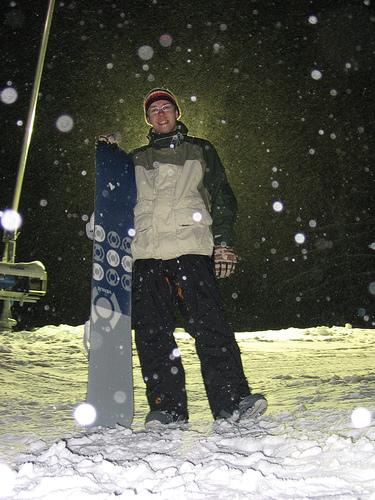What is the man holding?
Give a very brief answer. Snowboard. Is it snowing?
Short answer required. Yes. Is the man enjoying himself?
Write a very short answer. Yes. 